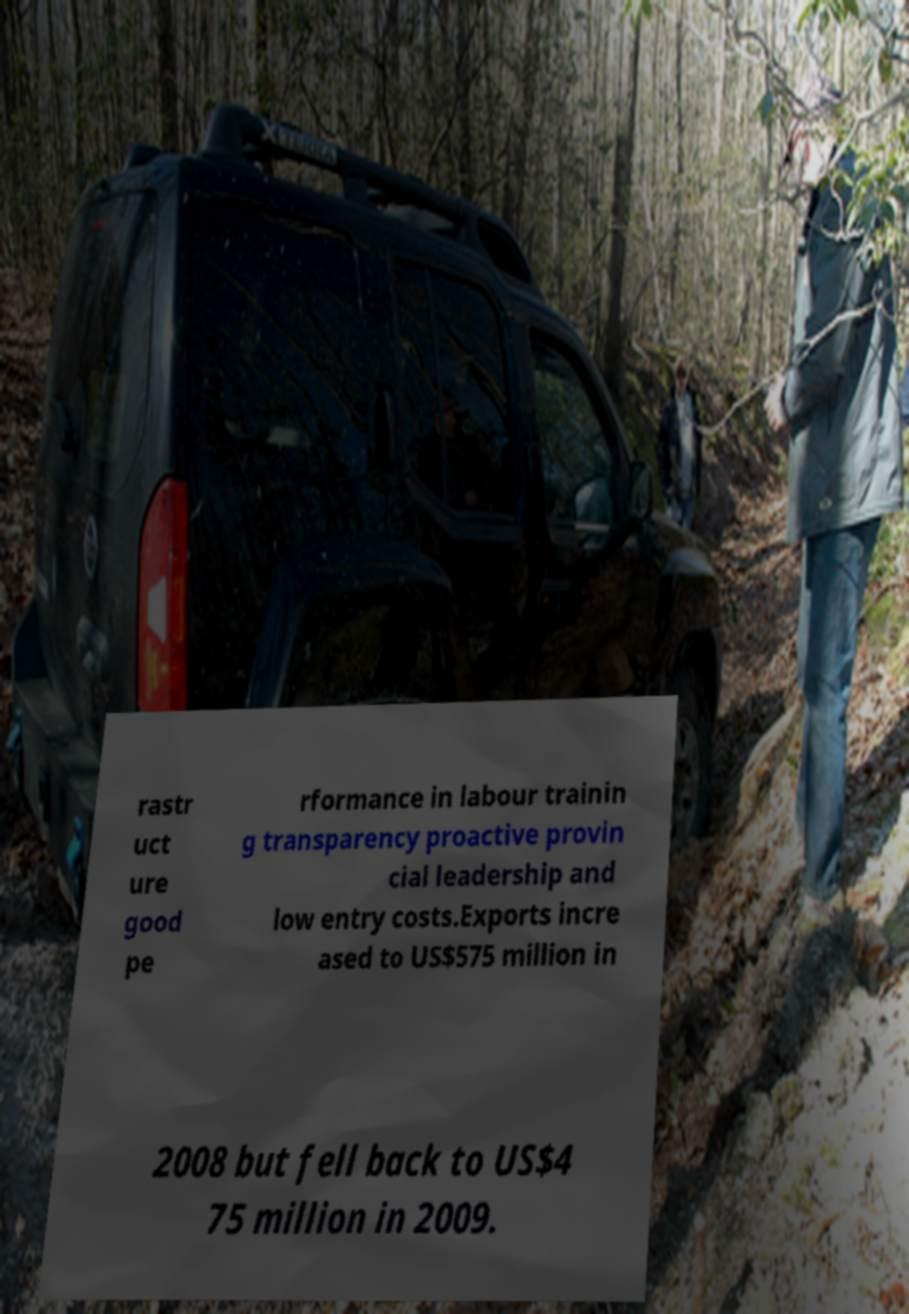What messages or text are displayed in this image? I need them in a readable, typed format. rastr uct ure good pe rformance in labour trainin g transparency proactive provin cial leadership and low entry costs.Exports incre ased to US$575 million in 2008 but fell back to US$4 75 million in 2009. 